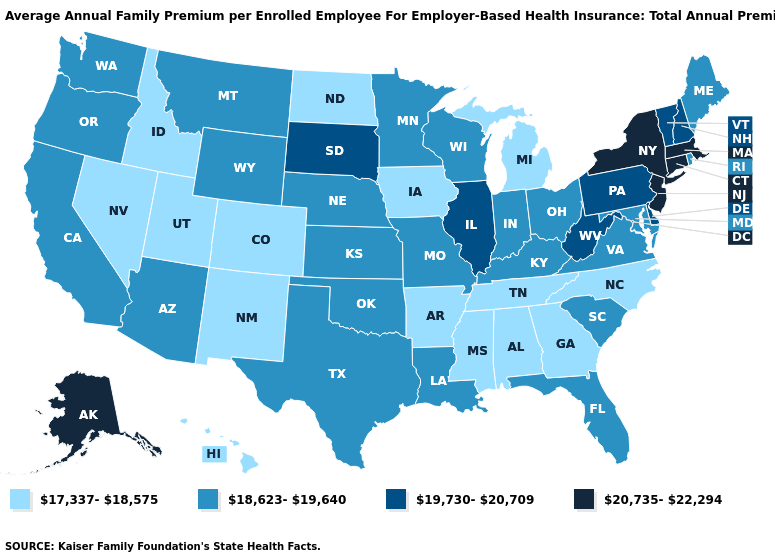Among the states that border New York , which have the highest value?
Concise answer only. Connecticut, Massachusetts, New Jersey. How many symbols are there in the legend?
Give a very brief answer. 4. Does the first symbol in the legend represent the smallest category?
Keep it brief. Yes. What is the value of Rhode Island?
Quick response, please. 18,623-19,640. Among the states that border Georgia , which have the lowest value?
Concise answer only. Alabama, North Carolina, Tennessee. What is the value of Arkansas?
Keep it brief. 17,337-18,575. Name the states that have a value in the range 18,623-19,640?
Answer briefly. Arizona, California, Florida, Indiana, Kansas, Kentucky, Louisiana, Maine, Maryland, Minnesota, Missouri, Montana, Nebraska, Ohio, Oklahoma, Oregon, Rhode Island, South Carolina, Texas, Virginia, Washington, Wisconsin, Wyoming. What is the value of Virginia?
Keep it brief. 18,623-19,640. Among the states that border Tennessee , which have the highest value?
Quick response, please. Kentucky, Missouri, Virginia. What is the value of Nebraska?
Keep it brief. 18,623-19,640. Does Rhode Island have the highest value in the Northeast?
Be succinct. No. What is the value of Massachusetts?
Concise answer only. 20,735-22,294. What is the value of Delaware?
Concise answer only. 19,730-20,709. Among the states that border Kansas , which have the highest value?
Give a very brief answer. Missouri, Nebraska, Oklahoma. What is the highest value in the USA?
Quick response, please. 20,735-22,294. 